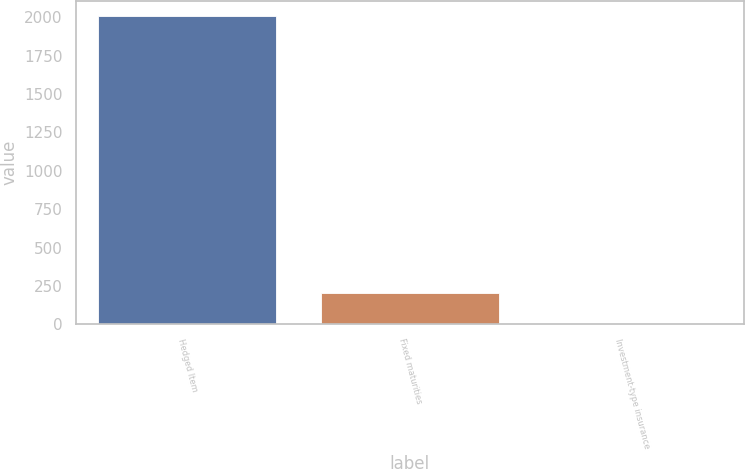<chart> <loc_0><loc_0><loc_500><loc_500><bar_chart><fcel>Hedged Item<fcel>Fixed maturities<fcel>Investment-type insurance<nl><fcel>2008<fcel>203.23<fcel>2.7<nl></chart> 